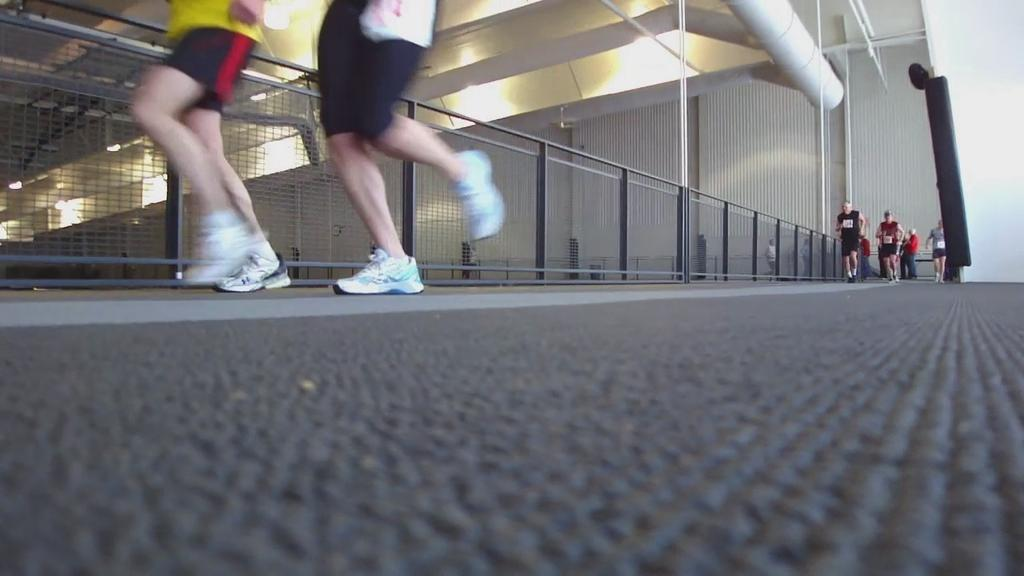What are the people in the foreground doing in the image? The people in the foreground are running. Can you describe the people visible in the image? There are people visible in the image, but their specific actions or characteristics are not mentioned in the provided facts. What can be seen in the background of the image? There appears to be a building and light in the background. What type of pipe can be seen connecting the building to the train in the image? There is no train or pipe present in the image. 